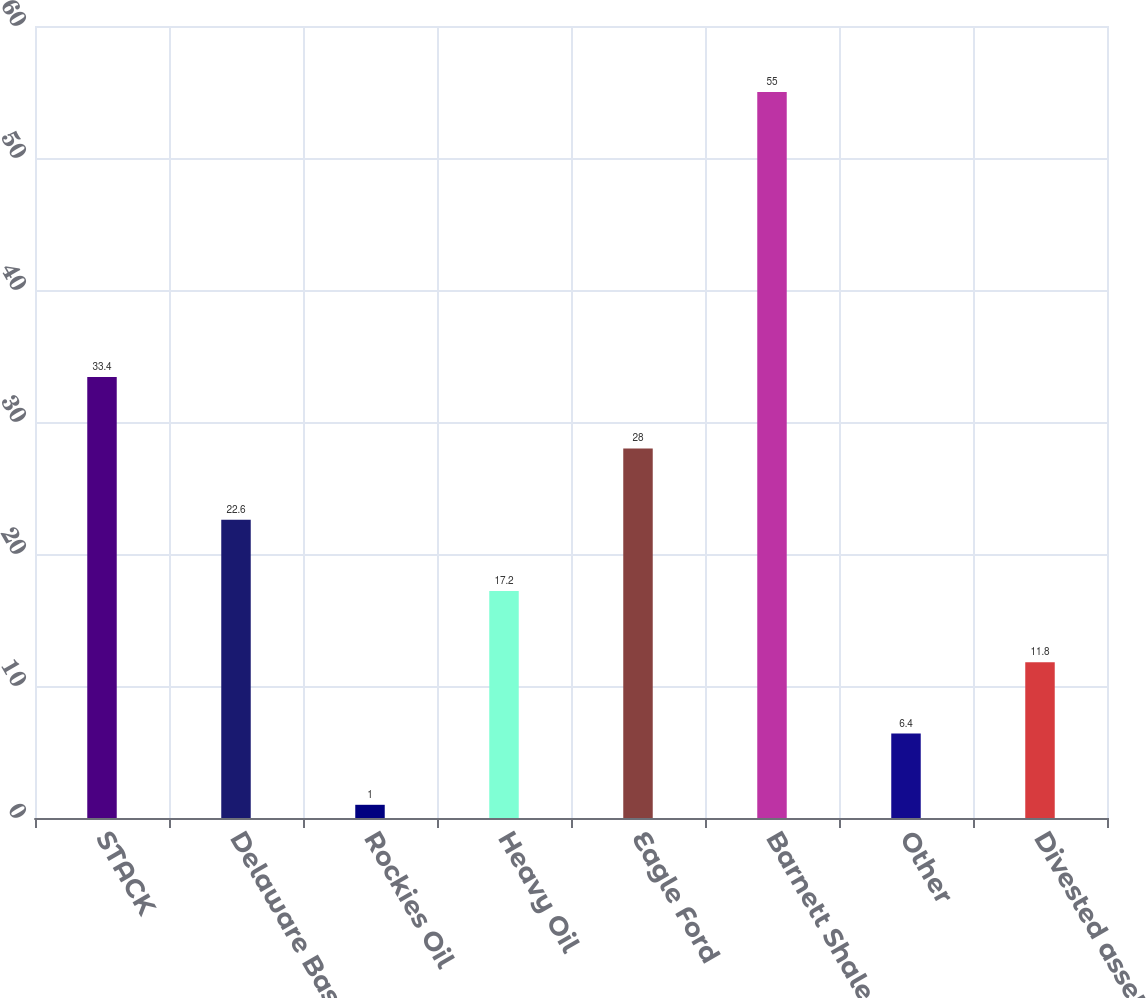Convert chart. <chart><loc_0><loc_0><loc_500><loc_500><bar_chart><fcel>STACK<fcel>Delaware Basin<fcel>Rockies Oil<fcel>Heavy Oil<fcel>Eagle Ford<fcel>Barnett Shale<fcel>Other<fcel>Divested assets<nl><fcel>33.4<fcel>22.6<fcel>1<fcel>17.2<fcel>28<fcel>55<fcel>6.4<fcel>11.8<nl></chart> 